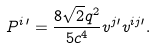Convert formula to latex. <formula><loc_0><loc_0><loc_500><loc_500>P ^ { i \, \prime } = \frac { 8 \sqrt { 2 } q ^ { 2 } } { 5 c ^ { 4 } } v ^ { j \prime } v ^ { i j \prime } .</formula> 